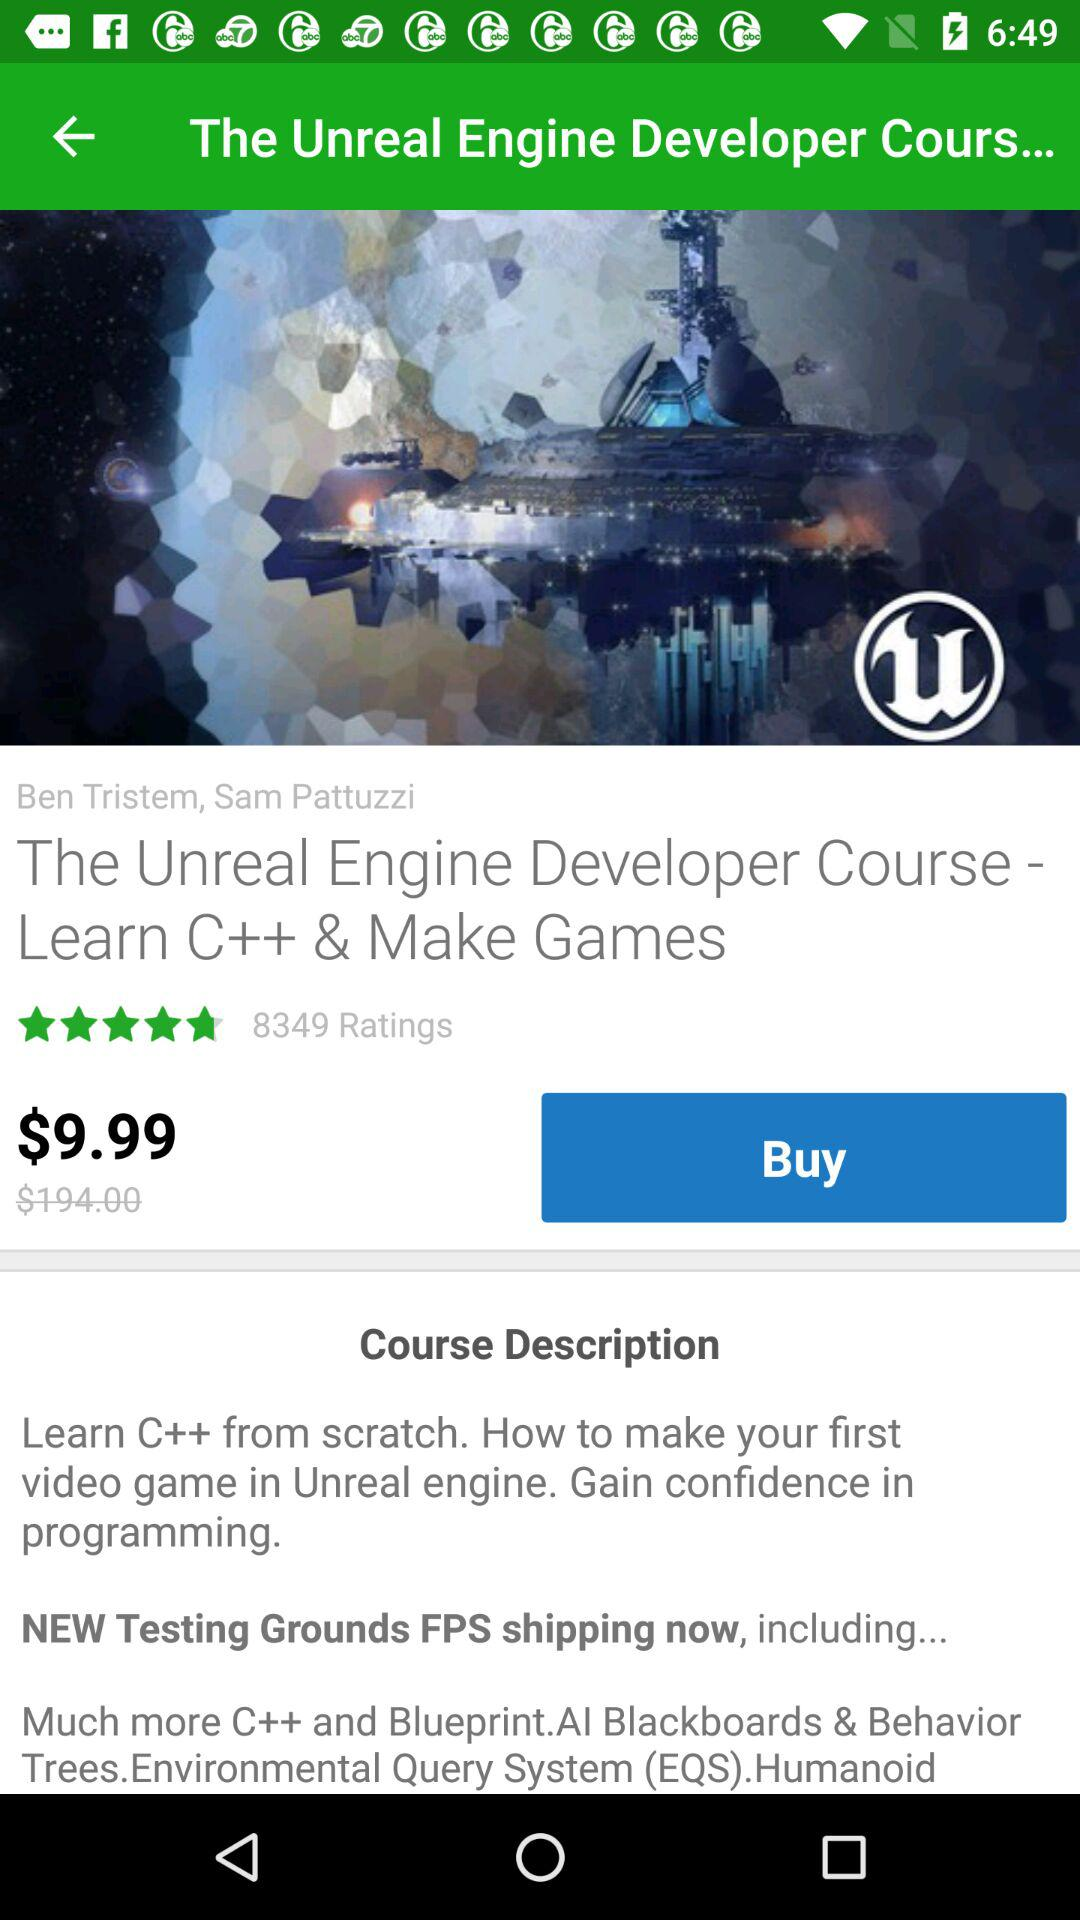What's the total number of ratings? The total number of ratings is 8349. 